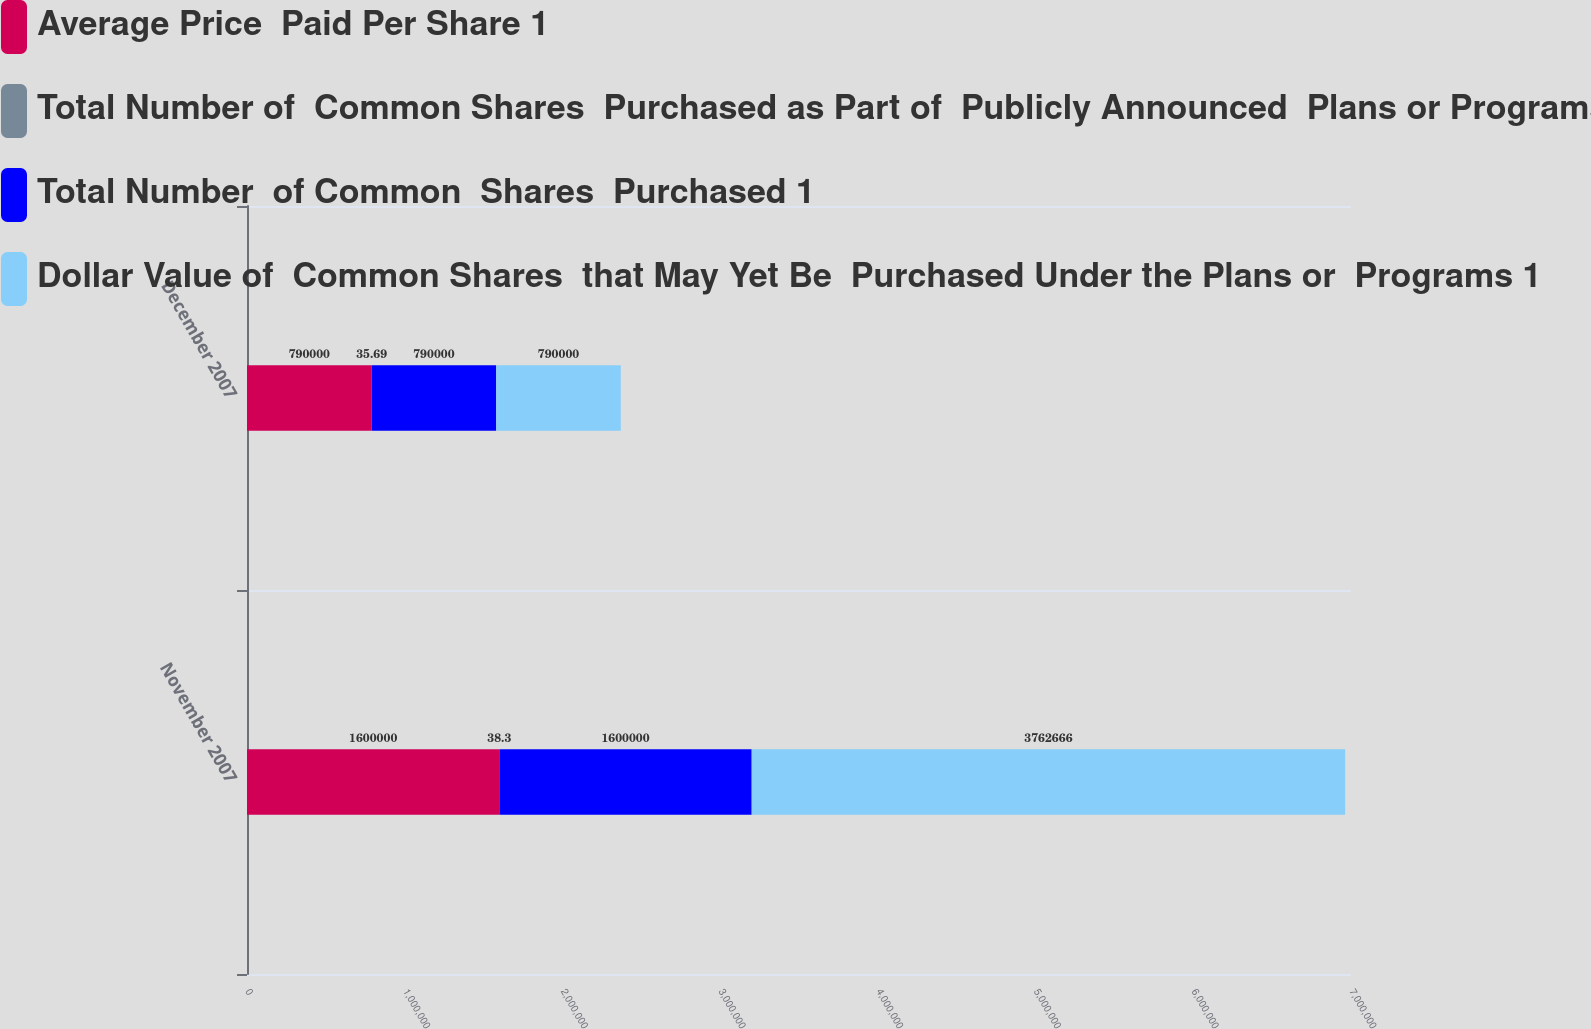Convert chart. <chart><loc_0><loc_0><loc_500><loc_500><stacked_bar_chart><ecel><fcel>November 2007<fcel>December 2007<nl><fcel>Average Price  Paid Per Share 1<fcel>1.6e+06<fcel>790000<nl><fcel>Total Number of  Common Shares  Purchased as Part of  Publicly Announced  Plans or Programs 1<fcel>38.3<fcel>35.69<nl><fcel>Total Number  of Common  Shares  Purchased 1<fcel>1.6e+06<fcel>790000<nl><fcel>Dollar Value of  Common Shares  that May Yet Be  Purchased Under the Plans or  Programs 1<fcel>3.76267e+06<fcel>790000<nl></chart> 